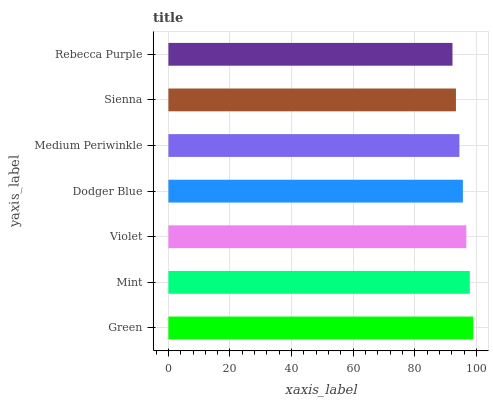Is Rebecca Purple the minimum?
Answer yes or no. Yes. Is Green the maximum?
Answer yes or no. Yes. Is Mint the minimum?
Answer yes or no. No. Is Mint the maximum?
Answer yes or no. No. Is Green greater than Mint?
Answer yes or no. Yes. Is Mint less than Green?
Answer yes or no. Yes. Is Mint greater than Green?
Answer yes or no. No. Is Green less than Mint?
Answer yes or no. No. Is Dodger Blue the high median?
Answer yes or no. Yes. Is Dodger Blue the low median?
Answer yes or no. Yes. Is Violet the high median?
Answer yes or no. No. Is Medium Periwinkle the low median?
Answer yes or no. No. 